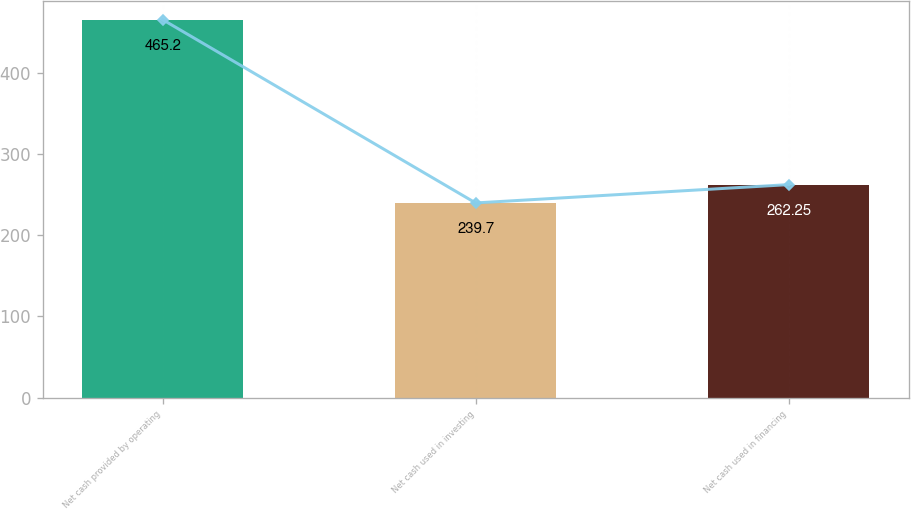Convert chart to OTSL. <chart><loc_0><loc_0><loc_500><loc_500><bar_chart><fcel>Net cash provided by operating<fcel>Net cash used in investing<fcel>Net cash used in financing<nl><fcel>465.2<fcel>239.7<fcel>262.25<nl></chart> 